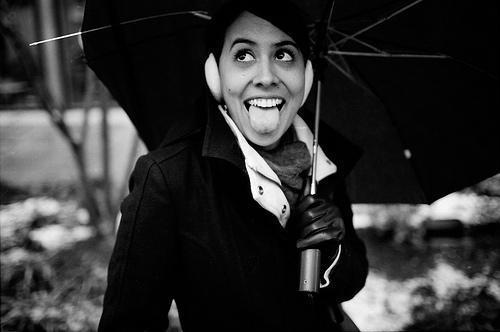How many snaps are on her shirt?
Give a very brief answer. 2. How many purple umbrellas is the person holding?
Give a very brief answer. 0. 